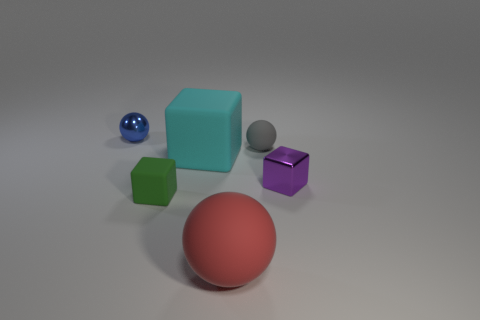There is a large object behind the small purple shiny object; does it have the same shape as the metallic thing that is right of the green matte cube? Yes, the large object positioned behind the small purple shiny object indeed has the same geometric shape as the metallic item located to the right of the green matte cube – both are cubes. However, their sizes, colors, and surface textures differ, with one being larger and turquoise with a matte finish, and the other being smaller, metallic, and placed in close proximity to the green cube. 